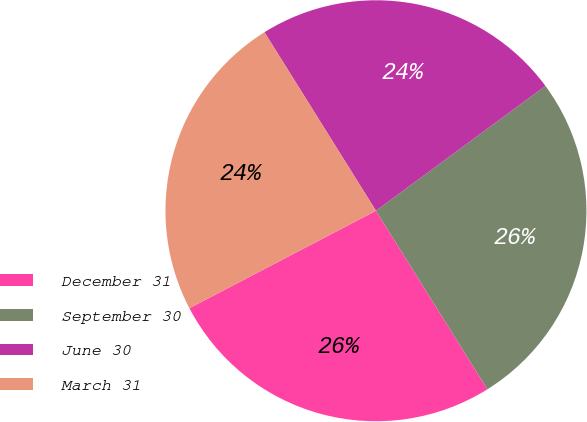<chart> <loc_0><loc_0><loc_500><loc_500><pie_chart><fcel>December 31<fcel>September 30<fcel>June 30<fcel>March 31<nl><fcel>26.22%<fcel>26.22%<fcel>23.78%<fcel>23.78%<nl></chart> 